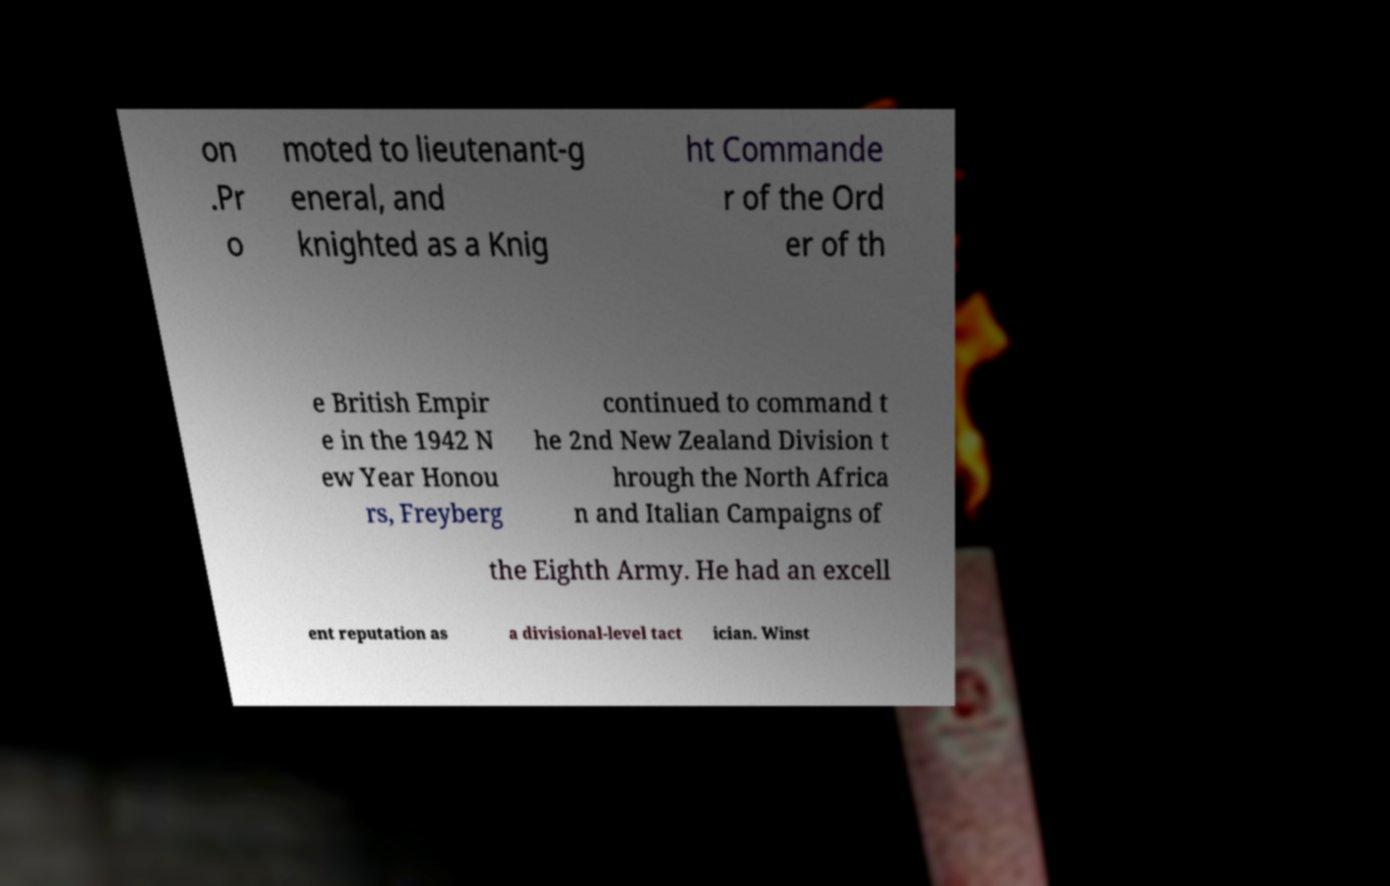Can you accurately transcribe the text from the provided image for me? on .Pr o moted to lieutenant-g eneral, and knighted as a Knig ht Commande r of the Ord er of th e British Empir e in the 1942 N ew Year Honou rs, Freyberg continued to command t he 2nd New Zealand Division t hrough the North Africa n and Italian Campaigns of the Eighth Army. He had an excell ent reputation as a divisional-level tact ician. Winst 